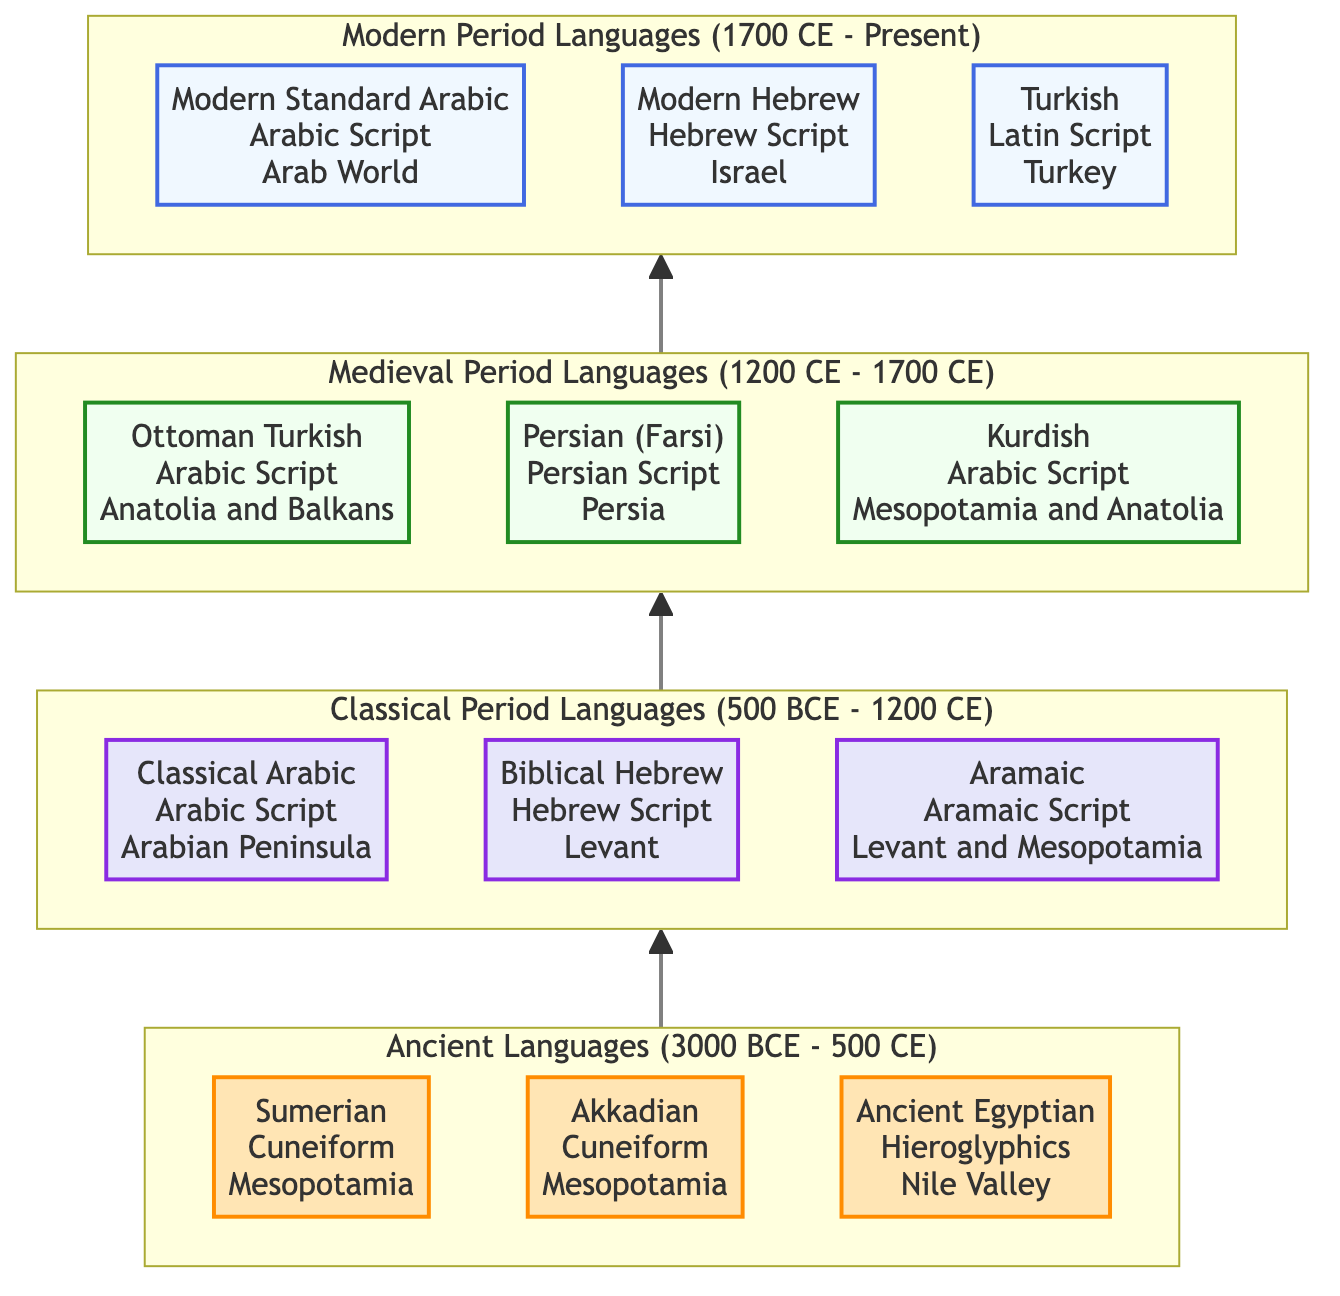What is the title of the diagram? The diagram's title is explicitly stated as "The Evolution of Middle Eastern Languages" at the top.
Answer: The Evolution of Middle Eastern Languages How many language stages are represented in the diagram? The diagram divides languages into four stages: Ancient, Classical, Medieval, and Modern. Thus, there are four distinct stages represented.
Answer: 4 Which script is associated with Sumerian? The diagram indicates that Sumerian is associated with Cuneiform, marked next to the language in the Ancient section.
Answer: Cuneiform What time period does the Medieval Period Languages cover? The information in the diagram shows that the Medieval Period Languages cover the time period of 1200 CE to 1700 CE, as labeled above that section.
Answer: 1200 CE - 1700 CE Which region is associated with Modern Standard Arabic? According to the diagram, Modern Standard Arabic is linked with the Arab World, mentioned directly in the Modern period section.
Answer: Arab World What writing system is used for Kurdish? Kurdish is connected to the Arabic Script, as shown in the Medieval Period Languages section of the diagram.
Answer: Arabic Script Which language comes directly after Classical Arabic in the flow? The flow of the diagram shows that after Classical Arabic, the next language is Biblical Hebrew, as it moves upward through the Classical stage.
Answer: Biblical Hebrew Identify the last language in the evolution chart. The final language in the Modern Period Languages section is Turkish, based on its position at the top of the diagram.
Answer: Turkish What relationship exists between Ancient Languages and Classical Period Languages? The diagram shows a direct upward flow from Ancient Languages to Classical Period Languages, indicating that Classical languages evolved from these earlier forms.
Answer: Direct upward flow 